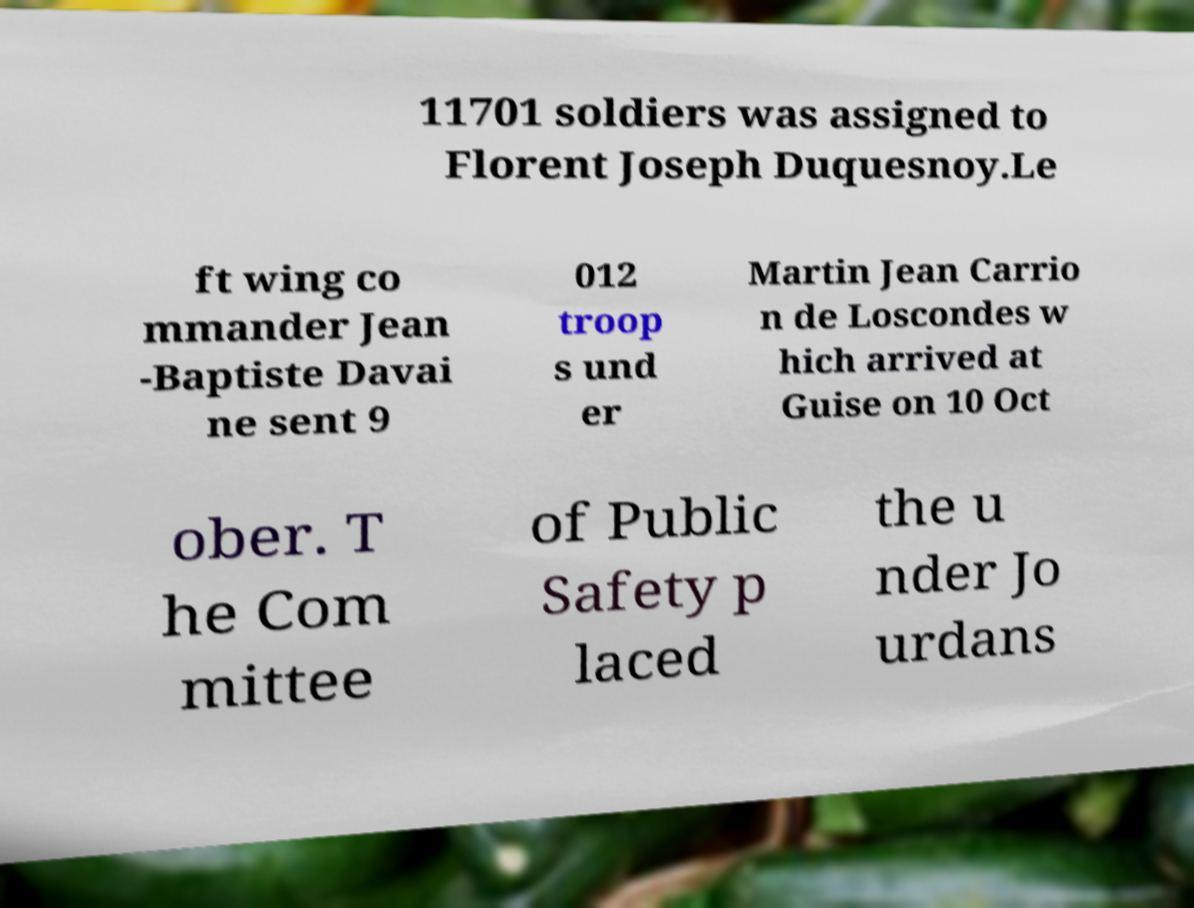Can you read and provide the text displayed in the image?This photo seems to have some interesting text. Can you extract and type it out for me? 11701 soldiers was assigned to Florent Joseph Duquesnoy.Le ft wing co mmander Jean -Baptiste Davai ne sent 9 012 troop s und er Martin Jean Carrio n de Loscondes w hich arrived at Guise on 10 Oct ober. T he Com mittee of Public Safety p laced the u nder Jo urdans 